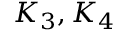<formula> <loc_0><loc_0><loc_500><loc_500>K _ { 3 } , K _ { 4 }</formula> 